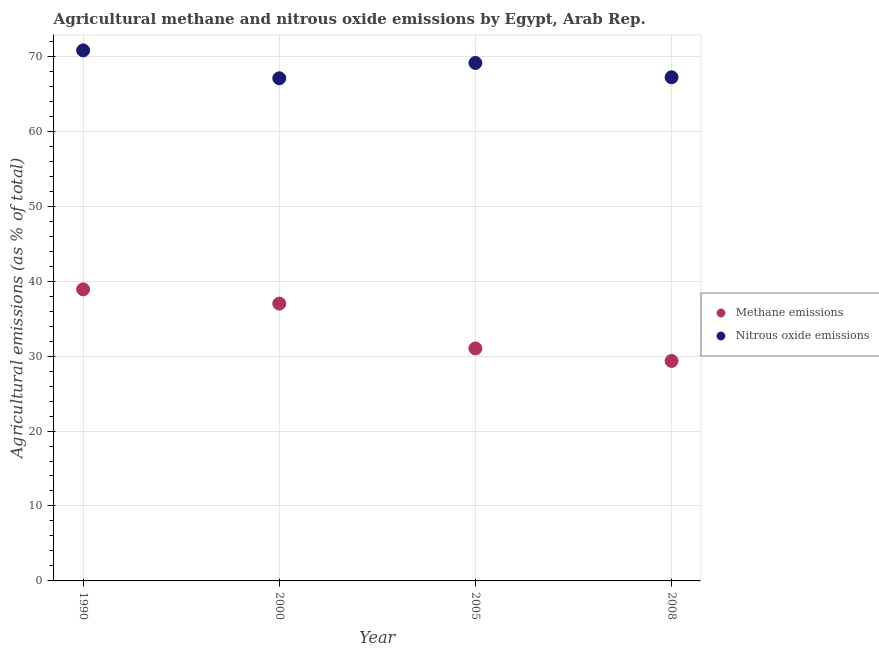What is the amount of nitrous oxide emissions in 2008?
Provide a short and direct response. 67.2. Across all years, what is the maximum amount of nitrous oxide emissions?
Keep it short and to the point. 70.79. Across all years, what is the minimum amount of nitrous oxide emissions?
Provide a succinct answer. 67.07. In which year was the amount of methane emissions maximum?
Your response must be concise. 1990. What is the total amount of methane emissions in the graph?
Provide a short and direct response. 136.28. What is the difference between the amount of nitrous oxide emissions in 2005 and that in 2008?
Offer a very short reply. 1.91. What is the difference between the amount of nitrous oxide emissions in 1990 and the amount of methane emissions in 2005?
Make the answer very short. 39.77. What is the average amount of nitrous oxide emissions per year?
Keep it short and to the point. 68.54. In the year 2000, what is the difference between the amount of nitrous oxide emissions and amount of methane emissions?
Ensure brevity in your answer.  30.07. In how many years, is the amount of methane emissions greater than 2 %?
Your answer should be very brief. 4. What is the ratio of the amount of methane emissions in 1990 to that in 2008?
Offer a terse response. 1.33. What is the difference between the highest and the second highest amount of nitrous oxide emissions?
Your answer should be compact. 1.68. What is the difference between the highest and the lowest amount of nitrous oxide emissions?
Offer a very short reply. 3.72. Does the amount of methane emissions monotonically increase over the years?
Provide a short and direct response. No. Is the amount of nitrous oxide emissions strictly greater than the amount of methane emissions over the years?
Ensure brevity in your answer.  Yes. How many years are there in the graph?
Your answer should be compact. 4. Are the values on the major ticks of Y-axis written in scientific E-notation?
Your answer should be very brief. No. How many legend labels are there?
Provide a short and direct response. 2. How are the legend labels stacked?
Give a very brief answer. Vertical. What is the title of the graph?
Ensure brevity in your answer.  Agricultural methane and nitrous oxide emissions by Egypt, Arab Rep. Does "Passenger Transport Items" appear as one of the legend labels in the graph?
Offer a very short reply. No. What is the label or title of the X-axis?
Keep it short and to the point. Year. What is the label or title of the Y-axis?
Your answer should be compact. Agricultural emissions (as % of total). What is the Agricultural emissions (as % of total) of Methane emissions in 1990?
Ensure brevity in your answer.  38.9. What is the Agricultural emissions (as % of total) in Nitrous oxide emissions in 1990?
Make the answer very short. 70.79. What is the Agricultural emissions (as % of total) in Methane emissions in 2000?
Provide a succinct answer. 37. What is the Agricultural emissions (as % of total) of Nitrous oxide emissions in 2000?
Offer a terse response. 67.07. What is the Agricultural emissions (as % of total) of Methane emissions in 2005?
Provide a short and direct response. 31.02. What is the Agricultural emissions (as % of total) in Nitrous oxide emissions in 2005?
Provide a succinct answer. 69.11. What is the Agricultural emissions (as % of total) in Methane emissions in 2008?
Provide a succinct answer. 29.35. What is the Agricultural emissions (as % of total) of Nitrous oxide emissions in 2008?
Give a very brief answer. 67.2. Across all years, what is the maximum Agricultural emissions (as % of total) in Methane emissions?
Ensure brevity in your answer.  38.9. Across all years, what is the maximum Agricultural emissions (as % of total) of Nitrous oxide emissions?
Provide a short and direct response. 70.79. Across all years, what is the minimum Agricultural emissions (as % of total) in Methane emissions?
Your answer should be compact. 29.35. Across all years, what is the minimum Agricultural emissions (as % of total) of Nitrous oxide emissions?
Ensure brevity in your answer.  67.07. What is the total Agricultural emissions (as % of total) of Methane emissions in the graph?
Offer a very short reply. 136.28. What is the total Agricultural emissions (as % of total) of Nitrous oxide emissions in the graph?
Offer a terse response. 274.17. What is the difference between the Agricultural emissions (as % of total) of Methane emissions in 1990 and that in 2000?
Give a very brief answer. 1.9. What is the difference between the Agricultural emissions (as % of total) of Nitrous oxide emissions in 1990 and that in 2000?
Give a very brief answer. 3.72. What is the difference between the Agricultural emissions (as % of total) of Methane emissions in 1990 and that in 2005?
Give a very brief answer. 7.88. What is the difference between the Agricultural emissions (as % of total) in Nitrous oxide emissions in 1990 and that in 2005?
Ensure brevity in your answer.  1.68. What is the difference between the Agricultural emissions (as % of total) in Methane emissions in 1990 and that in 2008?
Your answer should be compact. 9.55. What is the difference between the Agricultural emissions (as % of total) in Nitrous oxide emissions in 1990 and that in 2008?
Your answer should be compact. 3.59. What is the difference between the Agricultural emissions (as % of total) in Methane emissions in 2000 and that in 2005?
Provide a short and direct response. 5.98. What is the difference between the Agricultural emissions (as % of total) in Nitrous oxide emissions in 2000 and that in 2005?
Offer a terse response. -2.05. What is the difference between the Agricultural emissions (as % of total) in Methane emissions in 2000 and that in 2008?
Your answer should be compact. 7.65. What is the difference between the Agricultural emissions (as % of total) in Nitrous oxide emissions in 2000 and that in 2008?
Give a very brief answer. -0.14. What is the difference between the Agricultural emissions (as % of total) of Methane emissions in 2005 and that in 2008?
Your answer should be very brief. 1.67. What is the difference between the Agricultural emissions (as % of total) in Nitrous oxide emissions in 2005 and that in 2008?
Your response must be concise. 1.91. What is the difference between the Agricultural emissions (as % of total) in Methane emissions in 1990 and the Agricultural emissions (as % of total) in Nitrous oxide emissions in 2000?
Offer a terse response. -28.16. What is the difference between the Agricultural emissions (as % of total) in Methane emissions in 1990 and the Agricultural emissions (as % of total) in Nitrous oxide emissions in 2005?
Provide a succinct answer. -30.21. What is the difference between the Agricultural emissions (as % of total) of Methane emissions in 1990 and the Agricultural emissions (as % of total) of Nitrous oxide emissions in 2008?
Ensure brevity in your answer.  -28.3. What is the difference between the Agricultural emissions (as % of total) of Methane emissions in 2000 and the Agricultural emissions (as % of total) of Nitrous oxide emissions in 2005?
Your response must be concise. -32.11. What is the difference between the Agricultural emissions (as % of total) in Methane emissions in 2000 and the Agricultural emissions (as % of total) in Nitrous oxide emissions in 2008?
Ensure brevity in your answer.  -30.2. What is the difference between the Agricultural emissions (as % of total) in Methane emissions in 2005 and the Agricultural emissions (as % of total) in Nitrous oxide emissions in 2008?
Your response must be concise. -36.18. What is the average Agricultural emissions (as % of total) of Methane emissions per year?
Your answer should be compact. 34.07. What is the average Agricultural emissions (as % of total) of Nitrous oxide emissions per year?
Keep it short and to the point. 68.54. In the year 1990, what is the difference between the Agricultural emissions (as % of total) of Methane emissions and Agricultural emissions (as % of total) of Nitrous oxide emissions?
Provide a succinct answer. -31.88. In the year 2000, what is the difference between the Agricultural emissions (as % of total) of Methane emissions and Agricultural emissions (as % of total) of Nitrous oxide emissions?
Provide a succinct answer. -30.07. In the year 2005, what is the difference between the Agricultural emissions (as % of total) of Methane emissions and Agricultural emissions (as % of total) of Nitrous oxide emissions?
Your answer should be very brief. -38.09. In the year 2008, what is the difference between the Agricultural emissions (as % of total) in Methane emissions and Agricultural emissions (as % of total) in Nitrous oxide emissions?
Provide a succinct answer. -37.85. What is the ratio of the Agricultural emissions (as % of total) of Methane emissions in 1990 to that in 2000?
Provide a short and direct response. 1.05. What is the ratio of the Agricultural emissions (as % of total) of Nitrous oxide emissions in 1990 to that in 2000?
Make the answer very short. 1.06. What is the ratio of the Agricultural emissions (as % of total) in Methane emissions in 1990 to that in 2005?
Provide a short and direct response. 1.25. What is the ratio of the Agricultural emissions (as % of total) of Nitrous oxide emissions in 1990 to that in 2005?
Your answer should be compact. 1.02. What is the ratio of the Agricultural emissions (as % of total) of Methane emissions in 1990 to that in 2008?
Offer a very short reply. 1.33. What is the ratio of the Agricultural emissions (as % of total) in Nitrous oxide emissions in 1990 to that in 2008?
Your response must be concise. 1.05. What is the ratio of the Agricultural emissions (as % of total) of Methane emissions in 2000 to that in 2005?
Provide a succinct answer. 1.19. What is the ratio of the Agricultural emissions (as % of total) in Nitrous oxide emissions in 2000 to that in 2005?
Your answer should be very brief. 0.97. What is the ratio of the Agricultural emissions (as % of total) in Methane emissions in 2000 to that in 2008?
Offer a terse response. 1.26. What is the ratio of the Agricultural emissions (as % of total) in Methane emissions in 2005 to that in 2008?
Offer a very short reply. 1.06. What is the ratio of the Agricultural emissions (as % of total) in Nitrous oxide emissions in 2005 to that in 2008?
Your answer should be compact. 1.03. What is the difference between the highest and the second highest Agricultural emissions (as % of total) in Methane emissions?
Ensure brevity in your answer.  1.9. What is the difference between the highest and the second highest Agricultural emissions (as % of total) in Nitrous oxide emissions?
Give a very brief answer. 1.68. What is the difference between the highest and the lowest Agricultural emissions (as % of total) of Methane emissions?
Make the answer very short. 9.55. What is the difference between the highest and the lowest Agricultural emissions (as % of total) in Nitrous oxide emissions?
Make the answer very short. 3.72. 